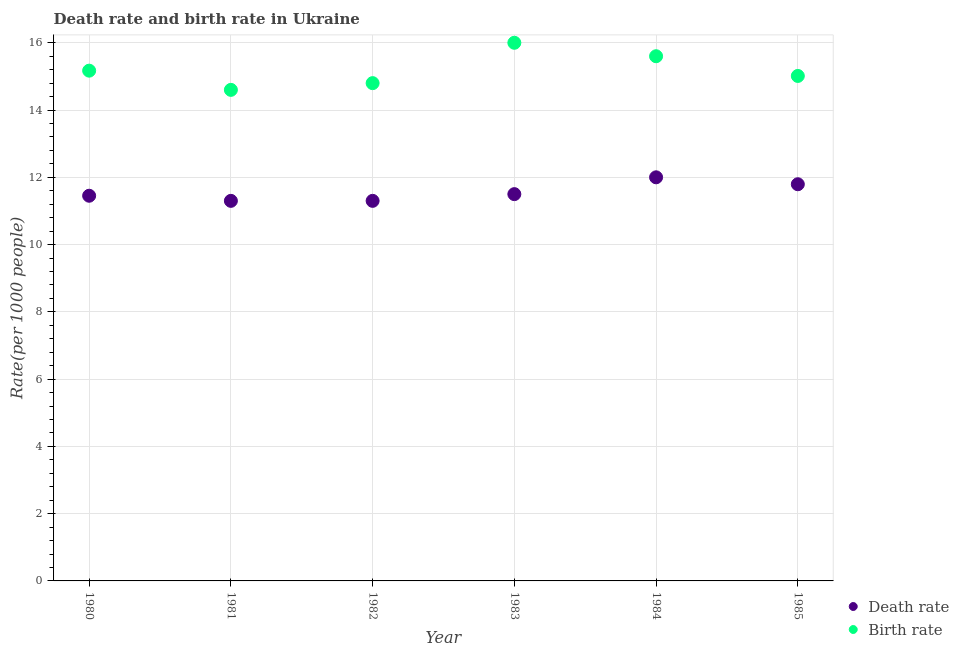Is the number of dotlines equal to the number of legend labels?
Your response must be concise. Yes. In which year was the death rate maximum?
Provide a short and direct response. 1984. What is the total death rate in the graph?
Your response must be concise. 69.35. What is the difference between the death rate in 1982 and that in 1985?
Your answer should be compact. -0.49. What is the difference between the birth rate in 1981 and the death rate in 1983?
Offer a very short reply. 3.1. What is the average death rate per year?
Provide a succinct answer. 11.56. In how many years, is the birth rate greater than 14.8?
Ensure brevity in your answer.  4. What is the ratio of the birth rate in 1984 to that in 1985?
Provide a short and direct response. 1.04. Is the difference between the death rate in 1980 and 1985 greater than the difference between the birth rate in 1980 and 1985?
Ensure brevity in your answer.  No. What is the difference between the highest and the second highest birth rate?
Make the answer very short. 0.4. What is the difference between the highest and the lowest birth rate?
Make the answer very short. 1.4. In how many years, is the death rate greater than the average death rate taken over all years?
Offer a terse response. 2. Is the sum of the death rate in 1981 and 1983 greater than the maximum birth rate across all years?
Give a very brief answer. Yes. How many dotlines are there?
Provide a succinct answer. 2. How many years are there in the graph?
Provide a succinct answer. 6. Does the graph contain any zero values?
Keep it short and to the point. No. Where does the legend appear in the graph?
Offer a terse response. Bottom right. How many legend labels are there?
Provide a short and direct response. 2. How are the legend labels stacked?
Your answer should be very brief. Vertical. What is the title of the graph?
Make the answer very short. Death rate and birth rate in Ukraine. Does "Time to export" appear as one of the legend labels in the graph?
Your answer should be compact. No. What is the label or title of the X-axis?
Offer a terse response. Year. What is the label or title of the Y-axis?
Ensure brevity in your answer.  Rate(per 1000 people). What is the Rate(per 1000 people) of Death rate in 1980?
Ensure brevity in your answer.  11.45. What is the Rate(per 1000 people) in Birth rate in 1980?
Give a very brief answer. 15.17. What is the Rate(per 1000 people) of Death rate in 1981?
Your answer should be very brief. 11.3. What is the Rate(per 1000 people) in Death rate in 1982?
Offer a very short reply. 11.3. What is the Rate(per 1000 people) of Birth rate in 1984?
Make the answer very short. 15.6. What is the Rate(per 1000 people) of Death rate in 1985?
Your response must be concise. 11.79. What is the Rate(per 1000 people) in Birth rate in 1985?
Your response must be concise. 15.01. Across all years, what is the minimum Rate(per 1000 people) of Death rate?
Provide a short and direct response. 11.3. Across all years, what is the minimum Rate(per 1000 people) of Birth rate?
Give a very brief answer. 14.6. What is the total Rate(per 1000 people) in Death rate in the graph?
Your answer should be very brief. 69.35. What is the total Rate(per 1000 people) in Birth rate in the graph?
Make the answer very short. 91.19. What is the difference between the Rate(per 1000 people) of Death rate in 1980 and that in 1981?
Provide a succinct answer. 0.15. What is the difference between the Rate(per 1000 people) in Birth rate in 1980 and that in 1981?
Give a very brief answer. 0.57. What is the difference between the Rate(per 1000 people) of Death rate in 1980 and that in 1982?
Make the answer very short. 0.15. What is the difference between the Rate(per 1000 people) of Birth rate in 1980 and that in 1982?
Give a very brief answer. 0.37. What is the difference between the Rate(per 1000 people) of Death rate in 1980 and that in 1983?
Ensure brevity in your answer.  -0.05. What is the difference between the Rate(per 1000 people) in Birth rate in 1980 and that in 1983?
Your answer should be compact. -0.83. What is the difference between the Rate(per 1000 people) in Death rate in 1980 and that in 1984?
Provide a short and direct response. -0.55. What is the difference between the Rate(per 1000 people) of Birth rate in 1980 and that in 1984?
Provide a succinct answer. -0.43. What is the difference between the Rate(per 1000 people) in Death rate in 1980 and that in 1985?
Provide a short and direct response. -0.34. What is the difference between the Rate(per 1000 people) of Birth rate in 1980 and that in 1985?
Provide a succinct answer. 0.16. What is the difference between the Rate(per 1000 people) of Birth rate in 1981 and that in 1983?
Provide a short and direct response. -1.4. What is the difference between the Rate(per 1000 people) in Death rate in 1981 and that in 1984?
Provide a succinct answer. -0.7. What is the difference between the Rate(per 1000 people) in Birth rate in 1981 and that in 1984?
Offer a very short reply. -1. What is the difference between the Rate(per 1000 people) in Death rate in 1981 and that in 1985?
Make the answer very short. -0.49. What is the difference between the Rate(per 1000 people) in Birth rate in 1981 and that in 1985?
Provide a succinct answer. -0.41. What is the difference between the Rate(per 1000 people) of Death rate in 1982 and that in 1984?
Provide a short and direct response. -0.7. What is the difference between the Rate(per 1000 people) of Death rate in 1982 and that in 1985?
Provide a short and direct response. -0.49. What is the difference between the Rate(per 1000 people) in Birth rate in 1982 and that in 1985?
Offer a terse response. -0.21. What is the difference between the Rate(per 1000 people) of Birth rate in 1983 and that in 1984?
Your response must be concise. 0.4. What is the difference between the Rate(per 1000 people) in Death rate in 1983 and that in 1985?
Provide a short and direct response. -0.29. What is the difference between the Rate(per 1000 people) in Death rate in 1984 and that in 1985?
Your answer should be very brief. 0.21. What is the difference between the Rate(per 1000 people) of Birth rate in 1984 and that in 1985?
Ensure brevity in your answer.  0.59. What is the difference between the Rate(per 1000 people) in Death rate in 1980 and the Rate(per 1000 people) in Birth rate in 1981?
Offer a very short reply. -3.15. What is the difference between the Rate(per 1000 people) of Death rate in 1980 and the Rate(per 1000 people) of Birth rate in 1982?
Provide a short and direct response. -3.35. What is the difference between the Rate(per 1000 people) of Death rate in 1980 and the Rate(per 1000 people) of Birth rate in 1983?
Your response must be concise. -4.55. What is the difference between the Rate(per 1000 people) in Death rate in 1980 and the Rate(per 1000 people) in Birth rate in 1984?
Offer a terse response. -4.15. What is the difference between the Rate(per 1000 people) in Death rate in 1980 and the Rate(per 1000 people) in Birth rate in 1985?
Keep it short and to the point. -3.56. What is the difference between the Rate(per 1000 people) of Death rate in 1981 and the Rate(per 1000 people) of Birth rate in 1982?
Make the answer very short. -3.5. What is the difference between the Rate(per 1000 people) in Death rate in 1981 and the Rate(per 1000 people) in Birth rate in 1985?
Keep it short and to the point. -3.71. What is the difference between the Rate(per 1000 people) of Death rate in 1982 and the Rate(per 1000 people) of Birth rate in 1983?
Give a very brief answer. -4.7. What is the difference between the Rate(per 1000 people) in Death rate in 1982 and the Rate(per 1000 people) in Birth rate in 1985?
Give a very brief answer. -3.71. What is the difference between the Rate(per 1000 people) of Death rate in 1983 and the Rate(per 1000 people) of Birth rate in 1985?
Provide a short and direct response. -3.51. What is the difference between the Rate(per 1000 people) in Death rate in 1984 and the Rate(per 1000 people) in Birth rate in 1985?
Provide a short and direct response. -3.01. What is the average Rate(per 1000 people) of Death rate per year?
Provide a short and direct response. 11.56. What is the average Rate(per 1000 people) in Birth rate per year?
Your answer should be very brief. 15.2. In the year 1980, what is the difference between the Rate(per 1000 people) in Death rate and Rate(per 1000 people) in Birth rate?
Offer a terse response. -3.72. In the year 1981, what is the difference between the Rate(per 1000 people) of Death rate and Rate(per 1000 people) of Birth rate?
Provide a short and direct response. -3.3. In the year 1983, what is the difference between the Rate(per 1000 people) in Death rate and Rate(per 1000 people) in Birth rate?
Your response must be concise. -4.5. In the year 1984, what is the difference between the Rate(per 1000 people) of Death rate and Rate(per 1000 people) of Birth rate?
Make the answer very short. -3.6. In the year 1985, what is the difference between the Rate(per 1000 people) of Death rate and Rate(per 1000 people) of Birth rate?
Make the answer very short. -3.22. What is the ratio of the Rate(per 1000 people) in Death rate in 1980 to that in 1981?
Keep it short and to the point. 1.01. What is the ratio of the Rate(per 1000 people) of Birth rate in 1980 to that in 1981?
Provide a succinct answer. 1.04. What is the ratio of the Rate(per 1000 people) in Death rate in 1980 to that in 1982?
Give a very brief answer. 1.01. What is the ratio of the Rate(per 1000 people) in Birth rate in 1980 to that in 1982?
Your answer should be compact. 1.03. What is the ratio of the Rate(per 1000 people) in Birth rate in 1980 to that in 1983?
Your answer should be very brief. 0.95. What is the ratio of the Rate(per 1000 people) of Death rate in 1980 to that in 1984?
Ensure brevity in your answer.  0.95. What is the ratio of the Rate(per 1000 people) in Birth rate in 1980 to that in 1984?
Make the answer very short. 0.97. What is the ratio of the Rate(per 1000 people) of Birth rate in 1980 to that in 1985?
Your answer should be compact. 1.01. What is the ratio of the Rate(per 1000 people) in Birth rate in 1981 to that in 1982?
Your answer should be compact. 0.99. What is the ratio of the Rate(per 1000 people) in Death rate in 1981 to that in 1983?
Offer a terse response. 0.98. What is the ratio of the Rate(per 1000 people) in Birth rate in 1981 to that in 1983?
Offer a terse response. 0.91. What is the ratio of the Rate(per 1000 people) in Death rate in 1981 to that in 1984?
Offer a terse response. 0.94. What is the ratio of the Rate(per 1000 people) of Birth rate in 1981 to that in 1984?
Provide a short and direct response. 0.94. What is the ratio of the Rate(per 1000 people) of Death rate in 1981 to that in 1985?
Provide a short and direct response. 0.96. What is the ratio of the Rate(per 1000 people) of Birth rate in 1981 to that in 1985?
Offer a very short reply. 0.97. What is the ratio of the Rate(per 1000 people) of Death rate in 1982 to that in 1983?
Your answer should be compact. 0.98. What is the ratio of the Rate(per 1000 people) in Birth rate in 1982 to that in 1983?
Your answer should be very brief. 0.93. What is the ratio of the Rate(per 1000 people) in Death rate in 1982 to that in 1984?
Provide a short and direct response. 0.94. What is the ratio of the Rate(per 1000 people) of Birth rate in 1982 to that in 1984?
Your response must be concise. 0.95. What is the ratio of the Rate(per 1000 people) in Death rate in 1982 to that in 1985?
Provide a short and direct response. 0.96. What is the ratio of the Rate(per 1000 people) of Birth rate in 1982 to that in 1985?
Provide a short and direct response. 0.99. What is the ratio of the Rate(per 1000 people) in Death rate in 1983 to that in 1984?
Your answer should be very brief. 0.96. What is the ratio of the Rate(per 1000 people) of Birth rate in 1983 to that in 1984?
Provide a short and direct response. 1.03. What is the ratio of the Rate(per 1000 people) in Death rate in 1983 to that in 1985?
Your answer should be compact. 0.98. What is the ratio of the Rate(per 1000 people) in Birth rate in 1983 to that in 1985?
Offer a terse response. 1.07. What is the ratio of the Rate(per 1000 people) in Death rate in 1984 to that in 1985?
Your answer should be very brief. 1.02. What is the ratio of the Rate(per 1000 people) of Birth rate in 1984 to that in 1985?
Provide a succinct answer. 1.04. What is the difference between the highest and the second highest Rate(per 1000 people) of Death rate?
Your answer should be compact. 0.21. What is the difference between the highest and the lowest Rate(per 1000 people) in Death rate?
Your answer should be compact. 0.7. 